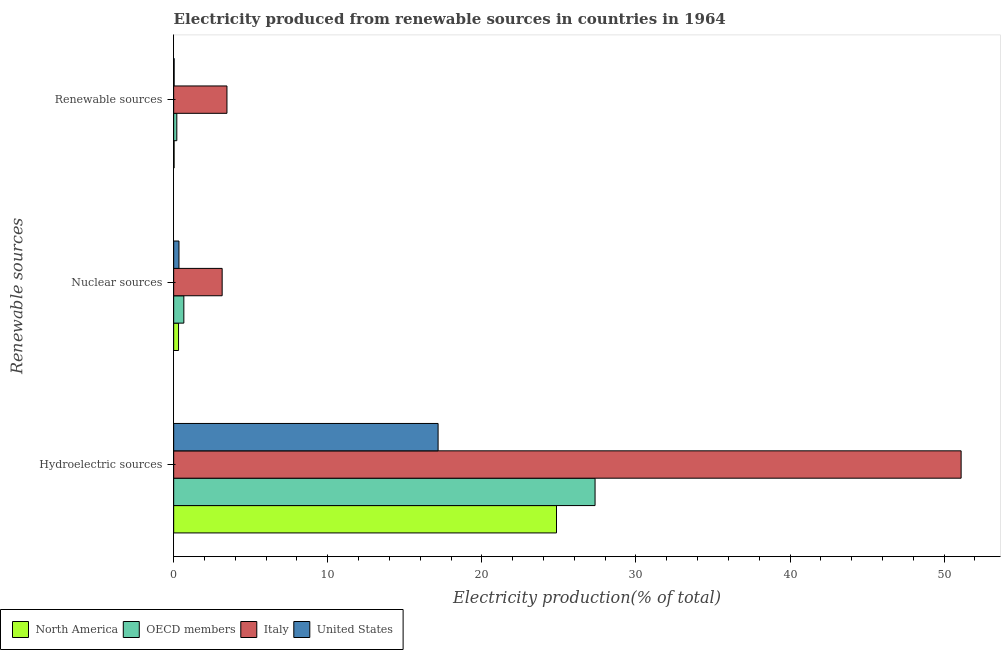How many different coloured bars are there?
Offer a very short reply. 4. How many groups of bars are there?
Your answer should be compact. 3. Are the number of bars on each tick of the Y-axis equal?
Offer a terse response. Yes. How many bars are there on the 3rd tick from the bottom?
Provide a short and direct response. 4. What is the label of the 3rd group of bars from the top?
Your answer should be very brief. Hydroelectric sources. What is the percentage of electricity produced by hydroelectric sources in OECD members?
Offer a very short reply. 27.35. Across all countries, what is the maximum percentage of electricity produced by hydroelectric sources?
Give a very brief answer. 51.1. Across all countries, what is the minimum percentage of electricity produced by renewable sources?
Your answer should be very brief. 0.03. In which country was the percentage of electricity produced by renewable sources minimum?
Your answer should be very brief. North America. What is the total percentage of electricity produced by hydroelectric sources in the graph?
Provide a short and direct response. 120.46. What is the difference between the percentage of electricity produced by renewable sources in North America and that in OECD members?
Provide a succinct answer. -0.18. What is the difference between the percentage of electricity produced by hydroelectric sources in OECD members and the percentage of electricity produced by nuclear sources in North America?
Ensure brevity in your answer.  27.03. What is the average percentage of electricity produced by hydroelectric sources per country?
Give a very brief answer. 30.11. What is the difference between the percentage of electricity produced by renewable sources and percentage of electricity produced by nuclear sources in OECD members?
Ensure brevity in your answer.  -0.46. In how many countries, is the percentage of electricity produced by hydroelectric sources greater than 38 %?
Offer a terse response. 1. What is the ratio of the percentage of electricity produced by nuclear sources in United States to that in North America?
Your answer should be very brief. 1.09. Is the percentage of electricity produced by nuclear sources in Italy less than that in North America?
Your answer should be compact. No. What is the difference between the highest and the second highest percentage of electricity produced by nuclear sources?
Your response must be concise. 2.49. What is the difference between the highest and the lowest percentage of electricity produced by nuclear sources?
Provide a short and direct response. 2.83. Is the sum of the percentage of electricity produced by nuclear sources in United States and North America greater than the maximum percentage of electricity produced by hydroelectric sources across all countries?
Offer a very short reply. No. What does the 4th bar from the top in Hydroelectric sources represents?
Keep it short and to the point. North America. How many countries are there in the graph?
Your answer should be compact. 4. What is the difference between two consecutive major ticks on the X-axis?
Your answer should be very brief. 10. Are the values on the major ticks of X-axis written in scientific E-notation?
Your answer should be compact. No. Does the graph contain any zero values?
Provide a short and direct response. No. Does the graph contain grids?
Offer a terse response. No. How are the legend labels stacked?
Your response must be concise. Horizontal. What is the title of the graph?
Your answer should be very brief. Electricity produced from renewable sources in countries in 1964. What is the label or title of the X-axis?
Your answer should be compact. Electricity production(% of total). What is the label or title of the Y-axis?
Provide a short and direct response. Renewable sources. What is the Electricity production(% of total) of North America in Hydroelectric sources?
Provide a short and direct response. 24.84. What is the Electricity production(% of total) in OECD members in Hydroelectric sources?
Your response must be concise. 27.35. What is the Electricity production(% of total) in Italy in Hydroelectric sources?
Your answer should be compact. 51.1. What is the Electricity production(% of total) of United States in Hydroelectric sources?
Provide a short and direct response. 17.16. What is the Electricity production(% of total) of North America in Nuclear sources?
Your answer should be compact. 0.32. What is the Electricity production(% of total) of OECD members in Nuclear sources?
Provide a succinct answer. 0.66. What is the Electricity production(% of total) in Italy in Nuclear sources?
Keep it short and to the point. 3.15. What is the Electricity production(% of total) of United States in Nuclear sources?
Ensure brevity in your answer.  0.34. What is the Electricity production(% of total) in North America in Renewable sources?
Your response must be concise. 0.03. What is the Electricity production(% of total) in OECD members in Renewable sources?
Keep it short and to the point. 0.2. What is the Electricity production(% of total) of Italy in Renewable sources?
Your answer should be very brief. 3.46. What is the Electricity production(% of total) in United States in Renewable sources?
Make the answer very short. 0.03. Across all Renewable sources, what is the maximum Electricity production(% of total) of North America?
Offer a terse response. 24.84. Across all Renewable sources, what is the maximum Electricity production(% of total) in OECD members?
Your answer should be compact. 27.35. Across all Renewable sources, what is the maximum Electricity production(% of total) of Italy?
Offer a very short reply. 51.1. Across all Renewable sources, what is the maximum Electricity production(% of total) of United States?
Your answer should be very brief. 17.16. Across all Renewable sources, what is the minimum Electricity production(% of total) of North America?
Provide a short and direct response. 0.03. Across all Renewable sources, what is the minimum Electricity production(% of total) in OECD members?
Offer a very short reply. 0.2. Across all Renewable sources, what is the minimum Electricity production(% of total) in Italy?
Your answer should be compact. 3.15. Across all Renewable sources, what is the minimum Electricity production(% of total) in United States?
Ensure brevity in your answer.  0.03. What is the total Electricity production(% of total) of North America in the graph?
Your answer should be very brief. 25.19. What is the total Electricity production(% of total) of OECD members in the graph?
Your answer should be very brief. 28.21. What is the total Electricity production(% of total) of Italy in the graph?
Your answer should be compact. 57.71. What is the total Electricity production(% of total) in United States in the graph?
Keep it short and to the point. 17.53. What is the difference between the Electricity production(% of total) of North America in Hydroelectric sources and that in Nuclear sources?
Provide a succinct answer. 24.53. What is the difference between the Electricity production(% of total) in OECD members in Hydroelectric sources and that in Nuclear sources?
Your answer should be very brief. 26.69. What is the difference between the Electricity production(% of total) of Italy in Hydroelectric sources and that in Nuclear sources?
Offer a very short reply. 47.96. What is the difference between the Electricity production(% of total) of United States in Hydroelectric sources and that in Nuclear sources?
Provide a short and direct response. 16.82. What is the difference between the Electricity production(% of total) of North America in Hydroelectric sources and that in Renewable sources?
Offer a terse response. 24.82. What is the difference between the Electricity production(% of total) in OECD members in Hydroelectric sources and that in Renewable sources?
Ensure brevity in your answer.  27.14. What is the difference between the Electricity production(% of total) in Italy in Hydroelectric sources and that in Renewable sources?
Your answer should be compact. 47.65. What is the difference between the Electricity production(% of total) in United States in Hydroelectric sources and that in Renewable sources?
Your answer should be very brief. 17.13. What is the difference between the Electricity production(% of total) in North America in Nuclear sources and that in Renewable sources?
Offer a terse response. 0.29. What is the difference between the Electricity production(% of total) in OECD members in Nuclear sources and that in Renewable sources?
Offer a terse response. 0.46. What is the difference between the Electricity production(% of total) in Italy in Nuclear sources and that in Renewable sources?
Provide a short and direct response. -0.31. What is the difference between the Electricity production(% of total) in United States in Nuclear sources and that in Renewable sources?
Keep it short and to the point. 0.31. What is the difference between the Electricity production(% of total) of North America in Hydroelectric sources and the Electricity production(% of total) of OECD members in Nuclear sources?
Keep it short and to the point. 24.18. What is the difference between the Electricity production(% of total) of North America in Hydroelectric sources and the Electricity production(% of total) of Italy in Nuclear sources?
Provide a short and direct response. 21.7. What is the difference between the Electricity production(% of total) in North America in Hydroelectric sources and the Electricity production(% of total) in United States in Nuclear sources?
Make the answer very short. 24.5. What is the difference between the Electricity production(% of total) of OECD members in Hydroelectric sources and the Electricity production(% of total) of Italy in Nuclear sources?
Make the answer very short. 24.2. What is the difference between the Electricity production(% of total) in OECD members in Hydroelectric sources and the Electricity production(% of total) in United States in Nuclear sources?
Your response must be concise. 27. What is the difference between the Electricity production(% of total) in Italy in Hydroelectric sources and the Electricity production(% of total) in United States in Nuclear sources?
Provide a short and direct response. 50.76. What is the difference between the Electricity production(% of total) of North America in Hydroelectric sources and the Electricity production(% of total) of OECD members in Renewable sources?
Provide a succinct answer. 24.64. What is the difference between the Electricity production(% of total) in North America in Hydroelectric sources and the Electricity production(% of total) in Italy in Renewable sources?
Make the answer very short. 21.39. What is the difference between the Electricity production(% of total) in North America in Hydroelectric sources and the Electricity production(% of total) in United States in Renewable sources?
Your answer should be compact. 24.81. What is the difference between the Electricity production(% of total) of OECD members in Hydroelectric sources and the Electricity production(% of total) of Italy in Renewable sources?
Your answer should be very brief. 23.89. What is the difference between the Electricity production(% of total) of OECD members in Hydroelectric sources and the Electricity production(% of total) of United States in Renewable sources?
Your response must be concise. 27.32. What is the difference between the Electricity production(% of total) in Italy in Hydroelectric sources and the Electricity production(% of total) in United States in Renewable sources?
Provide a succinct answer. 51.07. What is the difference between the Electricity production(% of total) of North America in Nuclear sources and the Electricity production(% of total) of OECD members in Renewable sources?
Make the answer very short. 0.11. What is the difference between the Electricity production(% of total) in North America in Nuclear sources and the Electricity production(% of total) in Italy in Renewable sources?
Give a very brief answer. -3.14. What is the difference between the Electricity production(% of total) in North America in Nuclear sources and the Electricity production(% of total) in United States in Renewable sources?
Keep it short and to the point. 0.29. What is the difference between the Electricity production(% of total) in OECD members in Nuclear sources and the Electricity production(% of total) in Italy in Renewable sources?
Your response must be concise. -2.8. What is the difference between the Electricity production(% of total) in OECD members in Nuclear sources and the Electricity production(% of total) in United States in Renewable sources?
Provide a short and direct response. 0.63. What is the difference between the Electricity production(% of total) of Italy in Nuclear sources and the Electricity production(% of total) of United States in Renewable sources?
Give a very brief answer. 3.12. What is the average Electricity production(% of total) of North America per Renewable sources?
Offer a very short reply. 8.4. What is the average Electricity production(% of total) of OECD members per Renewable sources?
Provide a short and direct response. 9.4. What is the average Electricity production(% of total) in Italy per Renewable sources?
Provide a short and direct response. 19.24. What is the average Electricity production(% of total) of United States per Renewable sources?
Provide a succinct answer. 5.84. What is the difference between the Electricity production(% of total) of North America and Electricity production(% of total) of OECD members in Hydroelectric sources?
Keep it short and to the point. -2.5. What is the difference between the Electricity production(% of total) of North America and Electricity production(% of total) of Italy in Hydroelectric sources?
Your response must be concise. -26.26. What is the difference between the Electricity production(% of total) of North America and Electricity production(% of total) of United States in Hydroelectric sources?
Your response must be concise. 7.68. What is the difference between the Electricity production(% of total) in OECD members and Electricity production(% of total) in Italy in Hydroelectric sources?
Your answer should be very brief. -23.76. What is the difference between the Electricity production(% of total) of OECD members and Electricity production(% of total) of United States in Hydroelectric sources?
Your answer should be very brief. 10.19. What is the difference between the Electricity production(% of total) of Italy and Electricity production(% of total) of United States in Hydroelectric sources?
Offer a very short reply. 33.94. What is the difference between the Electricity production(% of total) in North America and Electricity production(% of total) in OECD members in Nuclear sources?
Your response must be concise. -0.34. What is the difference between the Electricity production(% of total) in North America and Electricity production(% of total) in Italy in Nuclear sources?
Offer a very short reply. -2.83. What is the difference between the Electricity production(% of total) in North America and Electricity production(% of total) in United States in Nuclear sources?
Your response must be concise. -0.03. What is the difference between the Electricity production(% of total) in OECD members and Electricity production(% of total) in Italy in Nuclear sources?
Your response must be concise. -2.49. What is the difference between the Electricity production(% of total) in OECD members and Electricity production(% of total) in United States in Nuclear sources?
Provide a succinct answer. 0.32. What is the difference between the Electricity production(% of total) in Italy and Electricity production(% of total) in United States in Nuclear sources?
Your response must be concise. 2.8. What is the difference between the Electricity production(% of total) of North America and Electricity production(% of total) of OECD members in Renewable sources?
Provide a short and direct response. -0.18. What is the difference between the Electricity production(% of total) of North America and Electricity production(% of total) of Italy in Renewable sources?
Your response must be concise. -3.43. What is the difference between the Electricity production(% of total) in North America and Electricity production(% of total) in United States in Renewable sources?
Your response must be concise. -0. What is the difference between the Electricity production(% of total) in OECD members and Electricity production(% of total) in Italy in Renewable sources?
Provide a succinct answer. -3.25. What is the difference between the Electricity production(% of total) of OECD members and Electricity production(% of total) of United States in Renewable sources?
Ensure brevity in your answer.  0.17. What is the difference between the Electricity production(% of total) in Italy and Electricity production(% of total) in United States in Renewable sources?
Keep it short and to the point. 3.43. What is the ratio of the Electricity production(% of total) of North America in Hydroelectric sources to that in Nuclear sources?
Offer a very short reply. 78.65. What is the ratio of the Electricity production(% of total) in OECD members in Hydroelectric sources to that in Nuclear sources?
Your answer should be compact. 41.42. What is the ratio of the Electricity production(% of total) in Italy in Hydroelectric sources to that in Nuclear sources?
Ensure brevity in your answer.  16.24. What is the ratio of the Electricity production(% of total) in United States in Hydroelectric sources to that in Nuclear sources?
Your response must be concise. 49.99. What is the ratio of the Electricity production(% of total) of North America in Hydroelectric sources to that in Renewable sources?
Make the answer very short. 915.98. What is the ratio of the Electricity production(% of total) in OECD members in Hydroelectric sources to that in Renewable sources?
Your response must be concise. 134.44. What is the ratio of the Electricity production(% of total) in Italy in Hydroelectric sources to that in Renewable sources?
Give a very brief answer. 14.78. What is the ratio of the Electricity production(% of total) in United States in Hydroelectric sources to that in Renewable sources?
Make the answer very short. 558.66. What is the ratio of the Electricity production(% of total) of North America in Nuclear sources to that in Renewable sources?
Ensure brevity in your answer.  11.65. What is the ratio of the Electricity production(% of total) in OECD members in Nuclear sources to that in Renewable sources?
Provide a succinct answer. 3.25. What is the ratio of the Electricity production(% of total) of Italy in Nuclear sources to that in Renewable sources?
Offer a very short reply. 0.91. What is the ratio of the Electricity production(% of total) of United States in Nuclear sources to that in Renewable sources?
Provide a succinct answer. 11.18. What is the difference between the highest and the second highest Electricity production(% of total) in North America?
Keep it short and to the point. 24.53. What is the difference between the highest and the second highest Electricity production(% of total) in OECD members?
Offer a very short reply. 26.69. What is the difference between the highest and the second highest Electricity production(% of total) in Italy?
Provide a succinct answer. 47.65. What is the difference between the highest and the second highest Electricity production(% of total) of United States?
Your response must be concise. 16.82. What is the difference between the highest and the lowest Electricity production(% of total) in North America?
Offer a terse response. 24.82. What is the difference between the highest and the lowest Electricity production(% of total) of OECD members?
Your answer should be compact. 27.14. What is the difference between the highest and the lowest Electricity production(% of total) in Italy?
Your answer should be very brief. 47.96. What is the difference between the highest and the lowest Electricity production(% of total) in United States?
Offer a terse response. 17.13. 